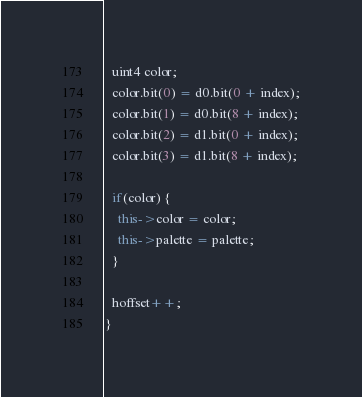<code> <loc_0><loc_0><loc_500><loc_500><_C++_>  uint4 color;
  color.bit(0) = d0.bit(0 + index);
  color.bit(1) = d0.bit(8 + index);
  color.bit(2) = d1.bit(0 + index);
  color.bit(3) = d1.bit(8 + index);

  if(color) {
    this->color = color;
    this->palette = palette;
  }

  hoffset++;
}
</code> 